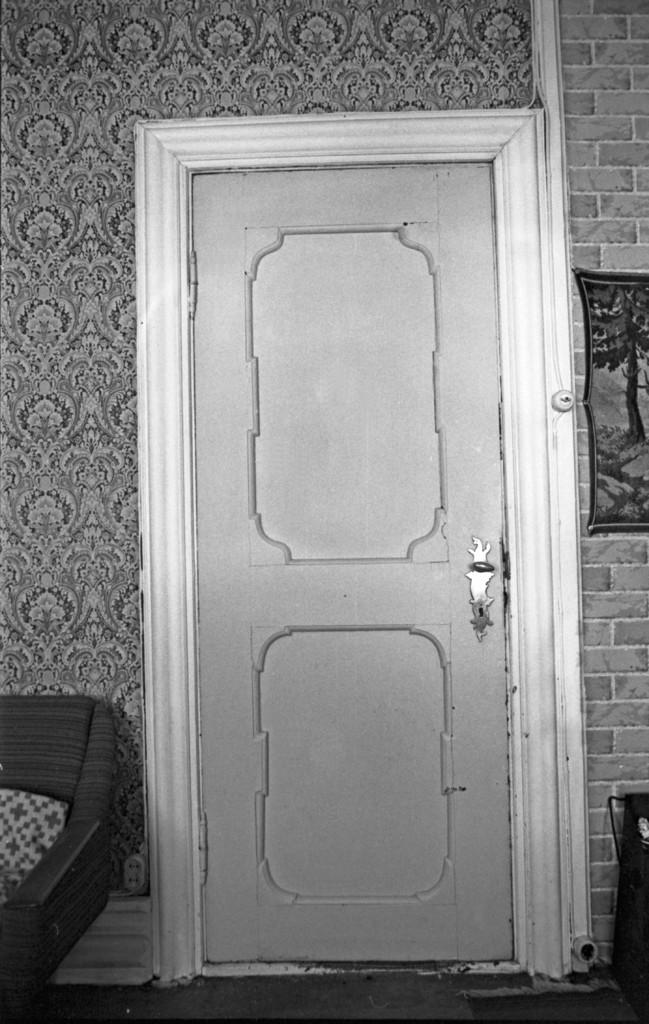What type of structure is visible in the image? There is a door and a brick wall in the image. What is hanging on the brick wall? There is a photo frame on the wall. What is the color scheme of the image? The image is black and white. How much does the elbow in the image weigh? There is no elbow present in the image. 